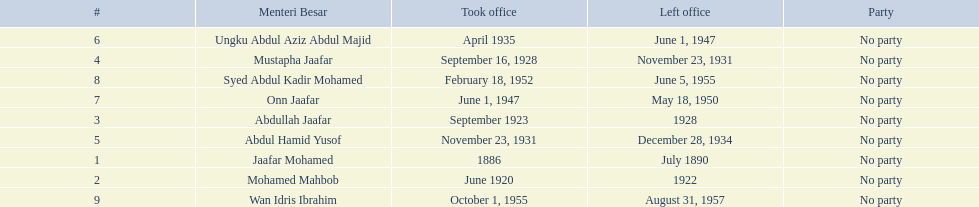When did jaafar mohamed take office? 1886. When did mohamed mahbob take office? June 1920. Who was in office no more than 4 years? Mohamed Mahbob. 